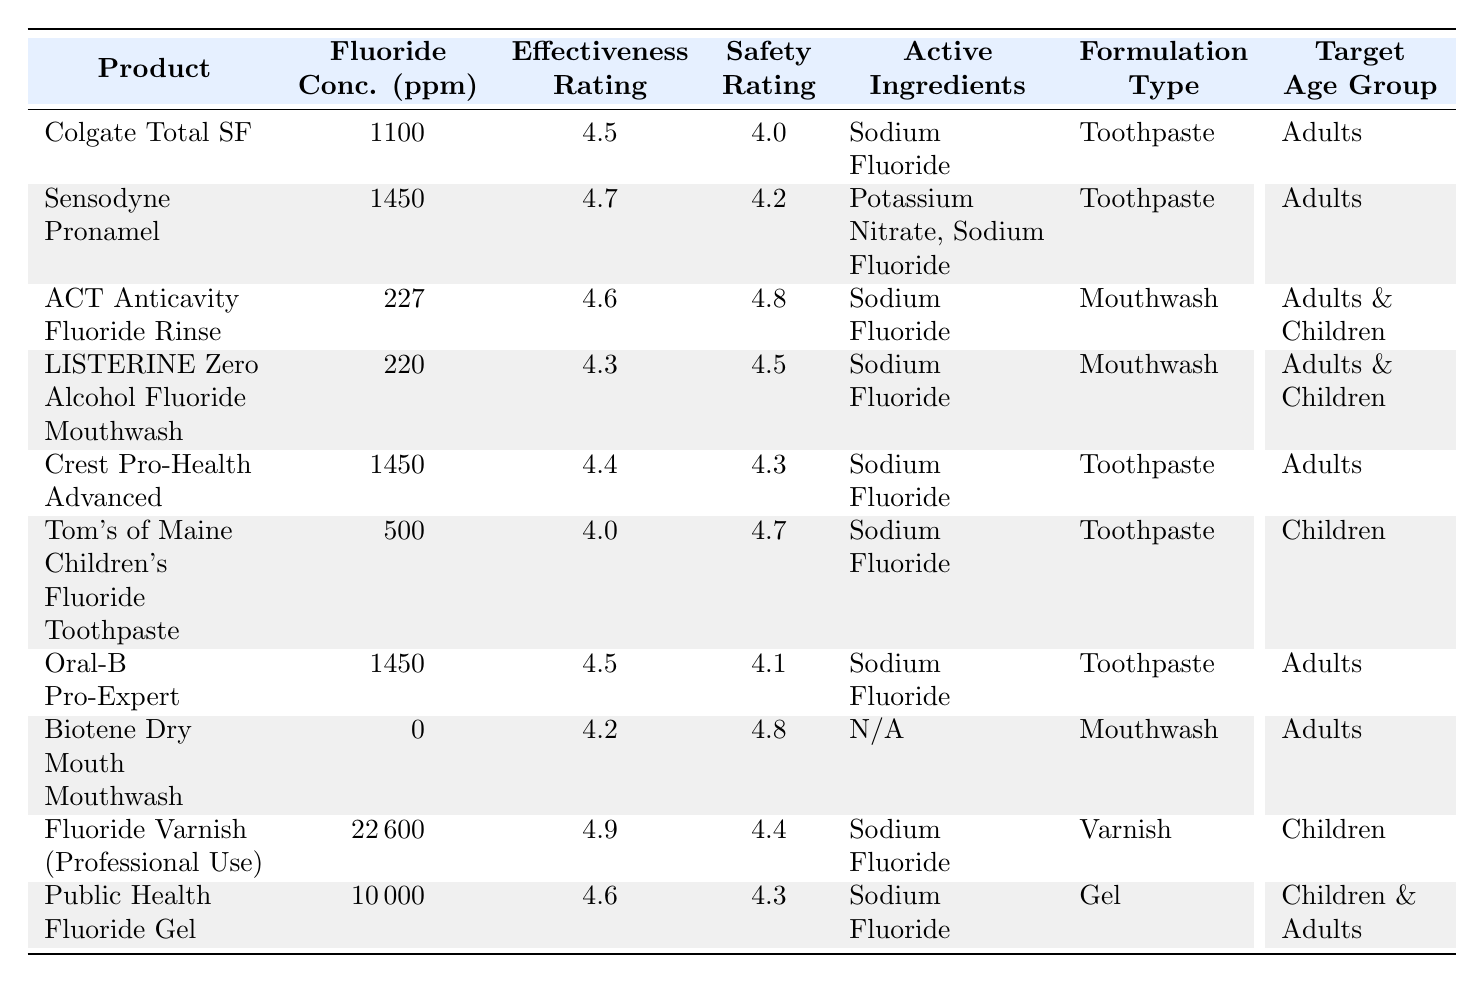What is the fluoride concentration of Sensodyne Pronamel? By examining the table, I find the row corresponding to Sensodyne Pronamel. The fluoride concentration value listed is 1450 ppm.
Answer: 1450 ppm Which product has the highest safety rating? Looking at the safety ratings across all products, Fluoride Varnish (Professional Use) has the highest rating of 4.9.
Answer: Fluoride Varnish (Professional Use) How do the effectiveness ratings of toothpaste compare to mouthwash? The effectiveness ratings for toothpaste are: Colgate Total SF (4.5), Sensodyne Pronamel (4.7), Crest Pro-Health Advanced (4.4), Oral-B Pro-Expert (4.5), and Tom's of Maine Children's Fluoride Toothpaste (4.0) averaging to 4.42. For mouthwash: ACT Anticavity Fluoride Rinse (4.6), LISTERINE Zero Alcohol Fluoride Mouthwash (4.3), and Biotene Dry Mouth Mouthwash (4.2) averaging to 4.37. Therefore, toothpaste has a higher average effectiveness rating than mouthwash.
Answer: Toothpaste is more effective on average What active ingredients are found in Tom's of Maine Children's Fluoride Toothpaste? The active ingredients for Tom's of Maine Children’s Fluoride Toothpaste are listed in the table as Sodium Fluoride.
Answer: Sodium Fluoride Is Biotene Dry Mouth Mouthwash effective? The effectiveness rating for Biotene Dry Mouth Mouthwash is 4.2, which is relatively high compared to other products, indicating it is effective.
Answer: Yes What is the difference in fluoride concentration between Fluoride Varnish (Professional Use) and Crest Pro-Health Advanced? Fluoride Varnish has a concentration of 22600 ppm while Crest Pro-Health Advanced has 1450 ppm. The difference is 22600 - 1450 = 21150 ppm.
Answer: 21150 ppm Which product has the lowest fluoride concentration, and what is its rating? The product with the lowest fluoride concentration is Biotene Dry Mouth Mouthwash with 0 ppm. Its effectiveness rating is 4.2, and the safety rating is 4.8.
Answer: 0 ppm, Effectiveness: 4.2, Safety: 4.8 How many products target children only? The table indicates that two products target children specifically: Tom's of Maine Children's Fluoride Toothpaste and Fluoride Varnish (Professional Use).
Answer: 2 What is the average effectiveness rating for products targeting adults? The products targeting adults are Colgate Total SF (4.5), Sensodyne Pronamel (4.7), Crest Pro-Health Advanced (4.4), Oral-B Pro-Expert (4.5), ACT Anticavity Fluoride Rinse (4.6), and LISTERINE Zero Alcohol (4.3). The average effectiveness is (4.5 + 4.7 + 4.4 + 4.5 + 4.6 + 4.3) / 6 = 4.4667, rounding to two decimal places gives us 4.47.
Answer: 4.47 Which product has a higher effectiveness rating, Fluoride Varnish (Professional Use) or Public Health Fluoride Gel? The effectiveness rating for Fluoride Varnish is 4.9, while for Public Health Fluoride Gel it is 4.6. Since 4.9 is greater than 4.6, Fluoride Varnish has a higher rating.
Answer: Fluoride Varnish (Professional Use) Are there any products with a fluoride concentration of zero? Yes, the table shows that Biotene Dry Mouth Mouthwash has a fluoride concentration of 0 ppm.
Answer: Yes 